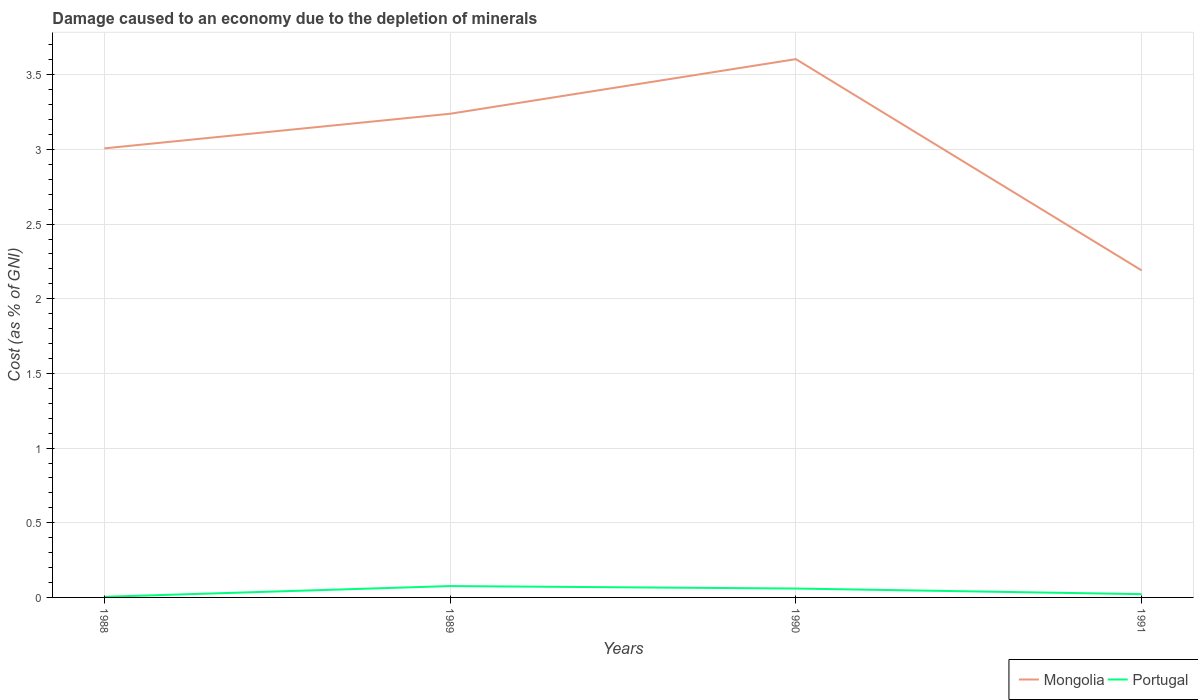How many different coloured lines are there?
Offer a very short reply. 2. Is the number of lines equal to the number of legend labels?
Offer a terse response. Yes. Across all years, what is the maximum cost of damage caused due to the depletion of minerals in Portugal?
Your response must be concise. 0. In which year was the cost of damage caused due to the depletion of minerals in Mongolia maximum?
Make the answer very short. 1991. What is the total cost of damage caused due to the depletion of minerals in Mongolia in the graph?
Ensure brevity in your answer.  0.82. What is the difference between the highest and the second highest cost of damage caused due to the depletion of minerals in Portugal?
Your response must be concise. 0.07. What is the difference between the highest and the lowest cost of damage caused due to the depletion of minerals in Portugal?
Provide a succinct answer. 2. Are the values on the major ticks of Y-axis written in scientific E-notation?
Your answer should be compact. No. Does the graph contain any zero values?
Offer a very short reply. No. Where does the legend appear in the graph?
Your answer should be very brief. Bottom right. How many legend labels are there?
Your answer should be compact. 2. How are the legend labels stacked?
Offer a terse response. Horizontal. What is the title of the graph?
Give a very brief answer. Damage caused to an economy due to the depletion of minerals. Does "Virgin Islands" appear as one of the legend labels in the graph?
Provide a succinct answer. No. What is the label or title of the Y-axis?
Keep it short and to the point. Cost (as % of GNI). What is the Cost (as % of GNI) of Mongolia in 1988?
Give a very brief answer. 3.01. What is the Cost (as % of GNI) of Portugal in 1988?
Provide a short and direct response. 0. What is the Cost (as % of GNI) of Mongolia in 1989?
Provide a short and direct response. 3.24. What is the Cost (as % of GNI) in Portugal in 1989?
Provide a short and direct response. 0.08. What is the Cost (as % of GNI) of Mongolia in 1990?
Your answer should be very brief. 3.6. What is the Cost (as % of GNI) of Portugal in 1990?
Your answer should be compact. 0.06. What is the Cost (as % of GNI) of Mongolia in 1991?
Your answer should be very brief. 2.19. What is the Cost (as % of GNI) of Portugal in 1991?
Offer a terse response. 0.02. Across all years, what is the maximum Cost (as % of GNI) in Mongolia?
Your answer should be compact. 3.6. Across all years, what is the maximum Cost (as % of GNI) of Portugal?
Your response must be concise. 0.08. Across all years, what is the minimum Cost (as % of GNI) in Mongolia?
Your response must be concise. 2.19. Across all years, what is the minimum Cost (as % of GNI) in Portugal?
Ensure brevity in your answer.  0. What is the total Cost (as % of GNI) in Mongolia in the graph?
Offer a terse response. 12.04. What is the total Cost (as % of GNI) in Portugal in the graph?
Keep it short and to the point. 0.16. What is the difference between the Cost (as % of GNI) in Mongolia in 1988 and that in 1989?
Make the answer very short. -0.23. What is the difference between the Cost (as % of GNI) of Portugal in 1988 and that in 1989?
Offer a terse response. -0.07. What is the difference between the Cost (as % of GNI) of Mongolia in 1988 and that in 1990?
Your answer should be very brief. -0.6. What is the difference between the Cost (as % of GNI) in Portugal in 1988 and that in 1990?
Give a very brief answer. -0.06. What is the difference between the Cost (as % of GNI) of Mongolia in 1988 and that in 1991?
Make the answer very short. 0.82. What is the difference between the Cost (as % of GNI) of Portugal in 1988 and that in 1991?
Keep it short and to the point. -0.02. What is the difference between the Cost (as % of GNI) in Mongolia in 1989 and that in 1990?
Keep it short and to the point. -0.37. What is the difference between the Cost (as % of GNI) of Portugal in 1989 and that in 1990?
Keep it short and to the point. 0.02. What is the difference between the Cost (as % of GNI) in Mongolia in 1989 and that in 1991?
Ensure brevity in your answer.  1.05. What is the difference between the Cost (as % of GNI) in Portugal in 1989 and that in 1991?
Make the answer very short. 0.05. What is the difference between the Cost (as % of GNI) of Mongolia in 1990 and that in 1991?
Your answer should be very brief. 1.41. What is the difference between the Cost (as % of GNI) in Portugal in 1990 and that in 1991?
Offer a terse response. 0.04. What is the difference between the Cost (as % of GNI) in Mongolia in 1988 and the Cost (as % of GNI) in Portugal in 1989?
Your answer should be compact. 2.93. What is the difference between the Cost (as % of GNI) in Mongolia in 1988 and the Cost (as % of GNI) in Portugal in 1990?
Make the answer very short. 2.95. What is the difference between the Cost (as % of GNI) of Mongolia in 1988 and the Cost (as % of GNI) of Portugal in 1991?
Ensure brevity in your answer.  2.98. What is the difference between the Cost (as % of GNI) of Mongolia in 1989 and the Cost (as % of GNI) of Portugal in 1990?
Provide a succinct answer. 3.18. What is the difference between the Cost (as % of GNI) of Mongolia in 1989 and the Cost (as % of GNI) of Portugal in 1991?
Keep it short and to the point. 3.22. What is the difference between the Cost (as % of GNI) of Mongolia in 1990 and the Cost (as % of GNI) of Portugal in 1991?
Provide a succinct answer. 3.58. What is the average Cost (as % of GNI) in Mongolia per year?
Give a very brief answer. 3.01. What is the average Cost (as % of GNI) in Portugal per year?
Offer a very short reply. 0.04. In the year 1988, what is the difference between the Cost (as % of GNI) in Mongolia and Cost (as % of GNI) in Portugal?
Offer a very short reply. 3. In the year 1989, what is the difference between the Cost (as % of GNI) in Mongolia and Cost (as % of GNI) in Portugal?
Make the answer very short. 3.16. In the year 1990, what is the difference between the Cost (as % of GNI) in Mongolia and Cost (as % of GNI) in Portugal?
Offer a very short reply. 3.54. In the year 1991, what is the difference between the Cost (as % of GNI) of Mongolia and Cost (as % of GNI) of Portugal?
Give a very brief answer. 2.17. What is the ratio of the Cost (as % of GNI) of Mongolia in 1988 to that in 1989?
Offer a very short reply. 0.93. What is the ratio of the Cost (as % of GNI) of Portugal in 1988 to that in 1989?
Ensure brevity in your answer.  0.05. What is the ratio of the Cost (as % of GNI) of Mongolia in 1988 to that in 1990?
Make the answer very short. 0.83. What is the ratio of the Cost (as % of GNI) of Portugal in 1988 to that in 1990?
Provide a succinct answer. 0.07. What is the ratio of the Cost (as % of GNI) of Mongolia in 1988 to that in 1991?
Your answer should be very brief. 1.37. What is the ratio of the Cost (as % of GNI) in Portugal in 1988 to that in 1991?
Your answer should be compact. 0.19. What is the ratio of the Cost (as % of GNI) in Mongolia in 1989 to that in 1990?
Keep it short and to the point. 0.9. What is the ratio of the Cost (as % of GNI) of Portugal in 1989 to that in 1990?
Offer a very short reply. 1.28. What is the ratio of the Cost (as % of GNI) in Mongolia in 1989 to that in 1991?
Your response must be concise. 1.48. What is the ratio of the Cost (as % of GNI) of Portugal in 1989 to that in 1991?
Make the answer very short. 3.46. What is the ratio of the Cost (as % of GNI) in Mongolia in 1990 to that in 1991?
Keep it short and to the point. 1.65. What is the ratio of the Cost (as % of GNI) of Portugal in 1990 to that in 1991?
Provide a short and direct response. 2.71. What is the difference between the highest and the second highest Cost (as % of GNI) of Mongolia?
Provide a succinct answer. 0.37. What is the difference between the highest and the second highest Cost (as % of GNI) in Portugal?
Your answer should be compact. 0.02. What is the difference between the highest and the lowest Cost (as % of GNI) of Mongolia?
Keep it short and to the point. 1.41. What is the difference between the highest and the lowest Cost (as % of GNI) in Portugal?
Give a very brief answer. 0.07. 